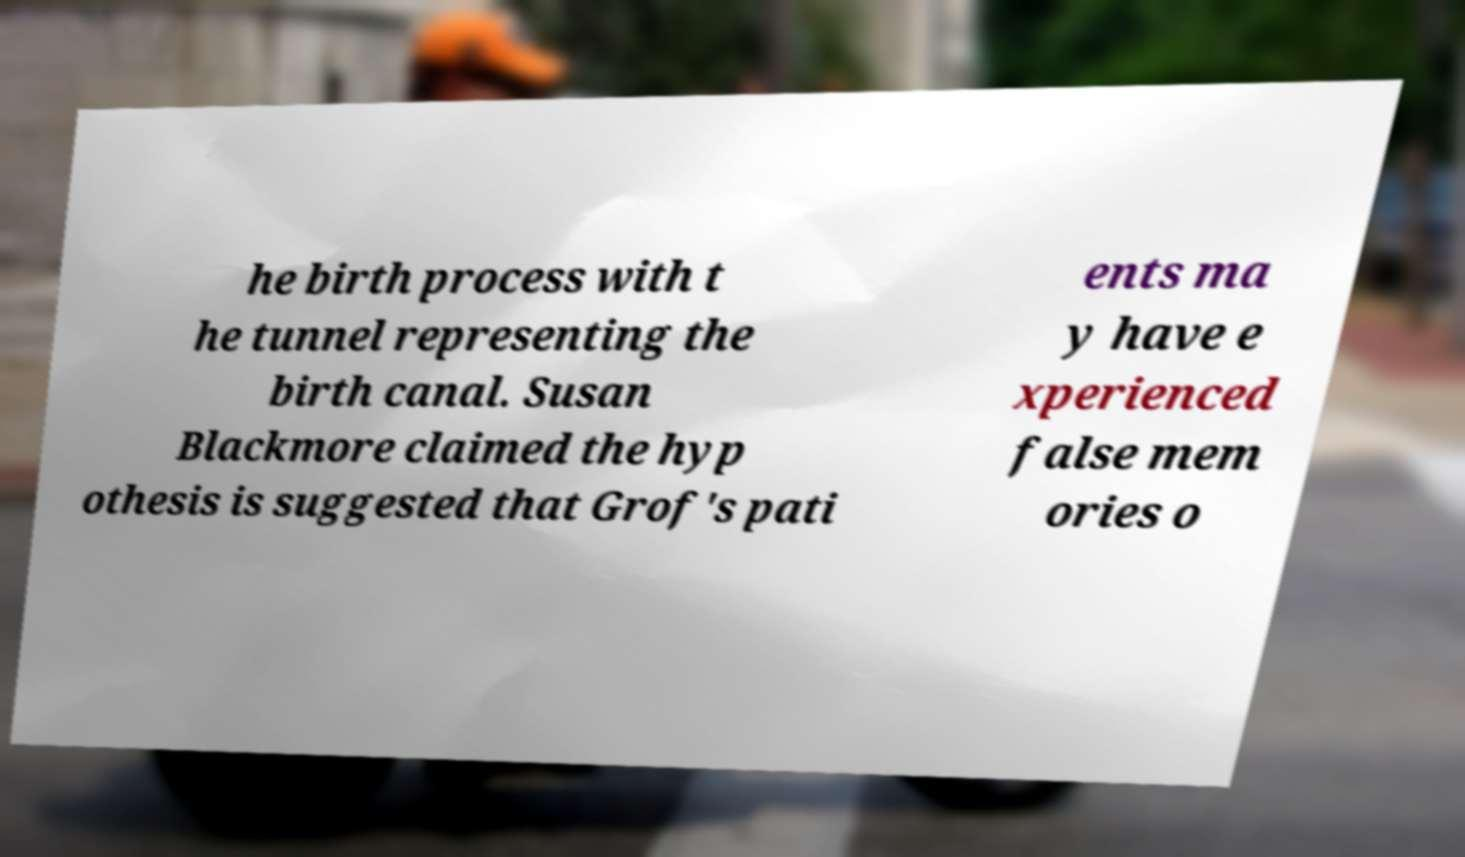Please read and relay the text visible in this image. What does it say? he birth process with t he tunnel representing the birth canal. Susan Blackmore claimed the hyp othesis is suggested that Grof's pati ents ma y have e xperienced false mem ories o 